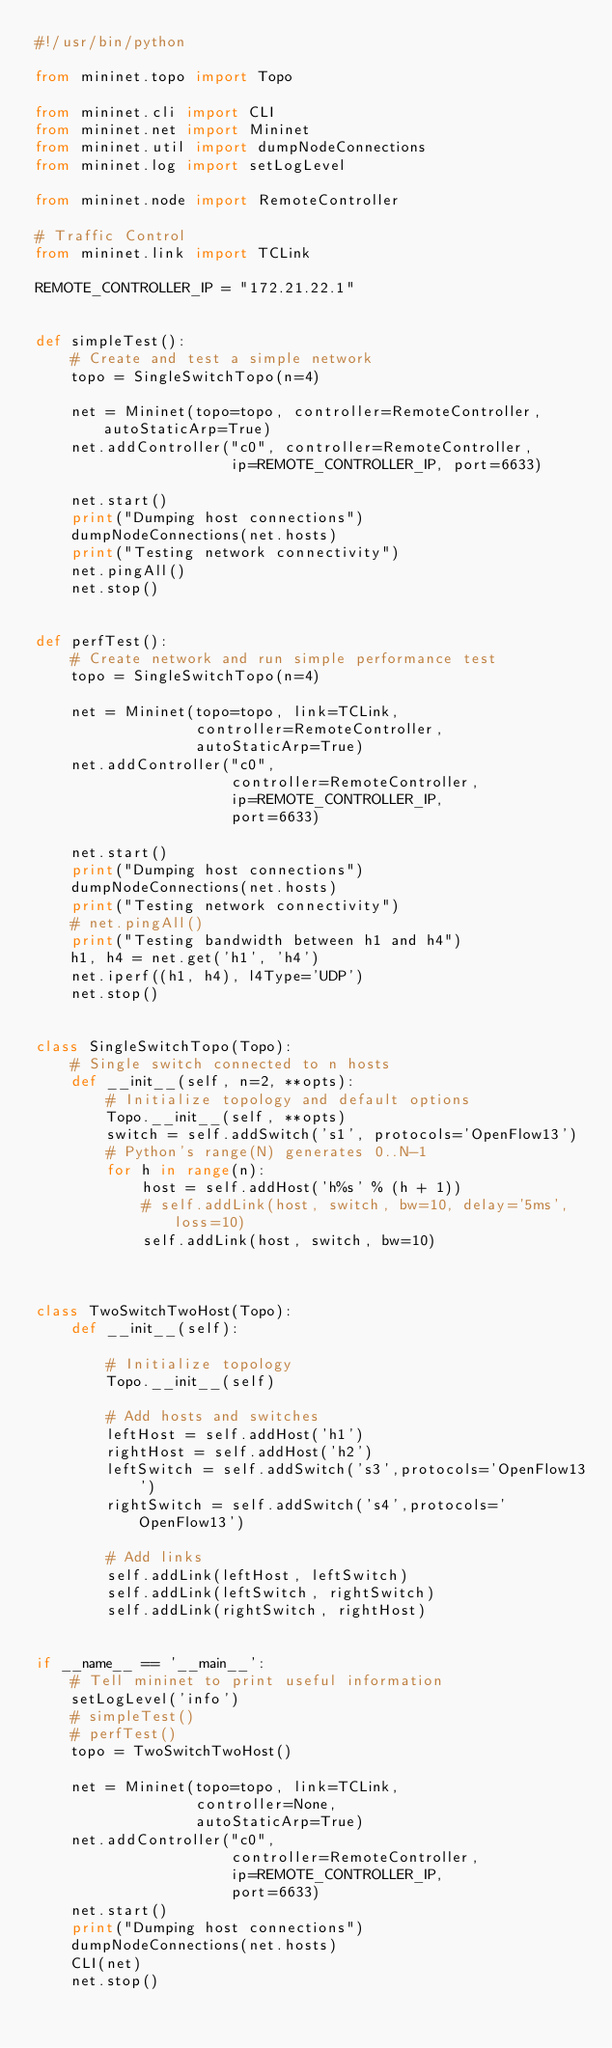<code> <loc_0><loc_0><loc_500><loc_500><_Python_>#!/usr/bin/python

from mininet.topo import Topo

from mininet.cli import CLI
from mininet.net import Mininet
from mininet.util import dumpNodeConnections
from mininet.log import setLogLevel

from mininet.node import RemoteController

# Traffic Control
from mininet.link import TCLink

REMOTE_CONTROLLER_IP = "172.21.22.1"


def simpleTest():
    # Create and test a simple network
    topo = SingleSwitchTopo(n=4)

    net = Mininet(topo=topo, controller=RemoteController, autoStaticArp=True)
    net.addController("c0", controller=RemoteController,
                      ip=REMOTE_CONTROLLER_IP, port=6633)

    net.start()
    print("Dumping host connections")
    dumpNodeConnections(net.hosts)
    print("Testing network connectivity")
    net.pingAll()
    net.stop()


def perfTest():
    # Create network and run simple performance test
    topo = SingleSwitchTopo(n=4)

    net = Mininet(topo=topo, link=TCLink,
                  controller=RemoteController,
                  autoStaticArp=True)
    net.addController("c0",
                      controller=RemoteController,
                      ip=REMOTE_CONTROLLER_IP,
                      port=6633)

    net.start()
    print("Dumping host connections")
    dumpNodeConnections(net.hosts)
    print("Testing network connectivity")
    # net.pingAll()
    print("Testing bandwidth between h1 and h4")
    h1, h4 = net.get('h1', 'h4')
    net.iperf((h1, h4), l4Type='UDP')
    net.stop()


class SingleSwitchTopo(Topo):
    # Single switch connected to n hosts
    def __init__(self, n=2, **opts):
        # Initialize topology and default options
        Topo.__init__(self, **opts)
        switch = self.addSwitch('s1', protocols='OpenFlow13')
        # Python's range(N) generates 0..N-1
        for h in range(n):
            host = self.addHost('h%s' % (h + 1))
            # self.addLink(host, switch, bw=10, delay='5ms', loss=10)
            self.addLink(host, switch, bw=10)



class TwoSwitchTwoHost(Topo):
    def __init__(self):

        # Initialize topology
        Topo.__init__(self)

        # Add hosts and switches
        leftHost = self.addHost('h1')
        rightHost = self.addHost('h2')
        leftSwitch = self.addSwitch('s3',protocols='OpenFlow13')
        rightSwitch = self.addSwitch('s4',protocols='OpenFlow13')

        # Add links
        self.addLink(leftHost, leftSwitch)
        self.addLink(leftSwitch, rightSwitch)
        self.addLink(rightSwitch, rightHost)


if __name__ == '__main__':
    # Tell mininet to print useful information
    setLogLevel('info')
    # simpleTest()
    # perfTest()
    topo = TwoSwitchTwoHost()

    net = Mininet(topo=topo, link=TCLink,
                  controller=None,
                  autoStaticArp=True)
    net.addController("c0",
                      controller=RemoteController,
                      ip=REMOTE_CONTROLLER_IP,
                      port=6633)
    net.start()
    print("Dumping host connections")
    dumpNodeConnections(net.hosts)
    CLI(net)
    net.stop()</code> 